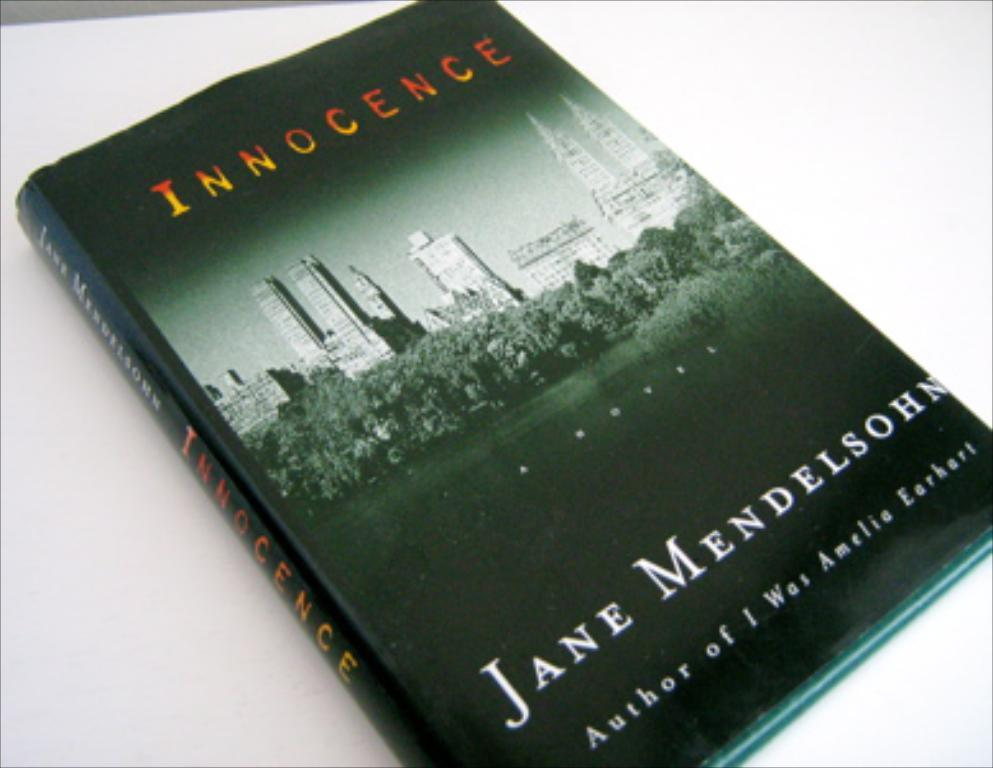<image>
Render a clear and concise summary of the photo. The book Innocence, written by Mendelsohn is laying on a table 